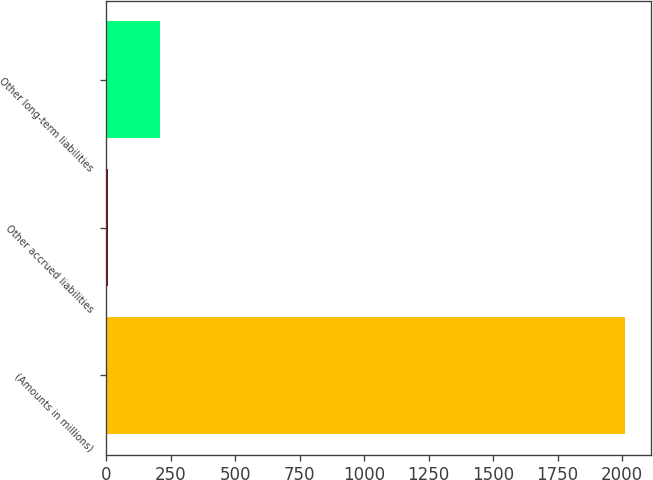Convert chart to OTSL. <chart><loc_0><loc_0><loc_500><loc_500><bar_chart><fcel>(Amounts in millions)<fcel>Other accrued liabilities<fcel>Other long-term liabilities<nl><fcel>2012<fcel>6.3<fcel>206.87<nl></chart> 